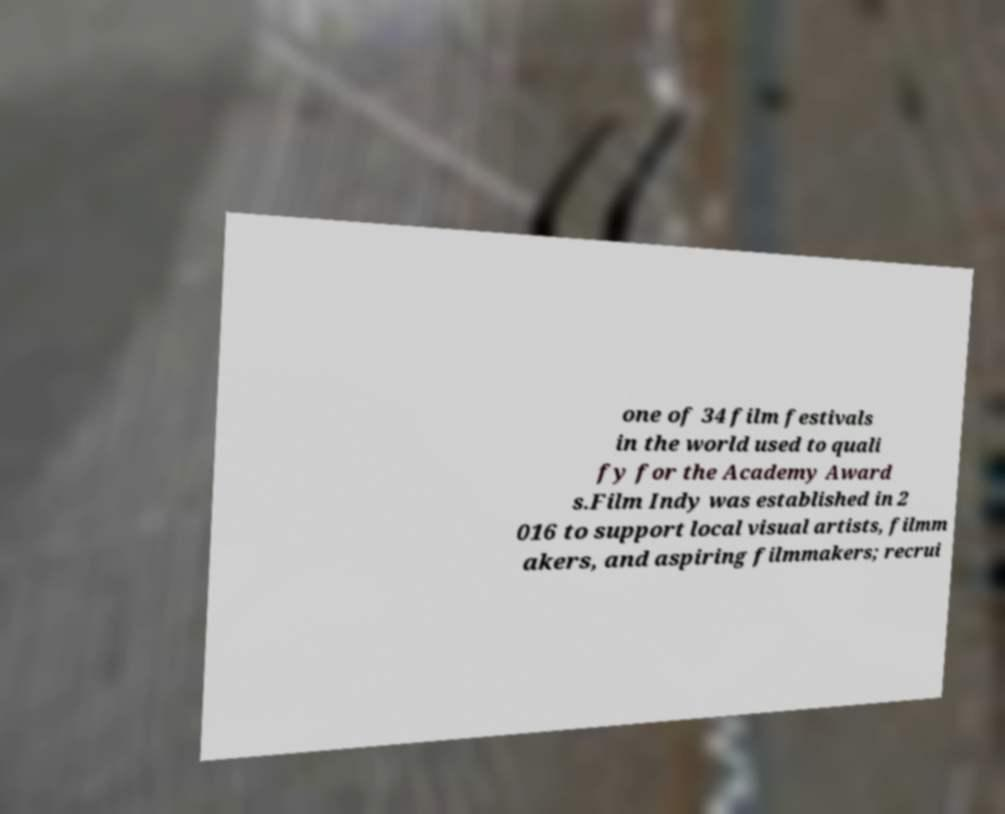Could you extract and type out the text from this image? one of 34 film festivals in the world used to quali fy for the Academy Award s.Film Indy was established in 2 016 to support local visual artists, filmm akers, and aspiring filmmakers; recrui 